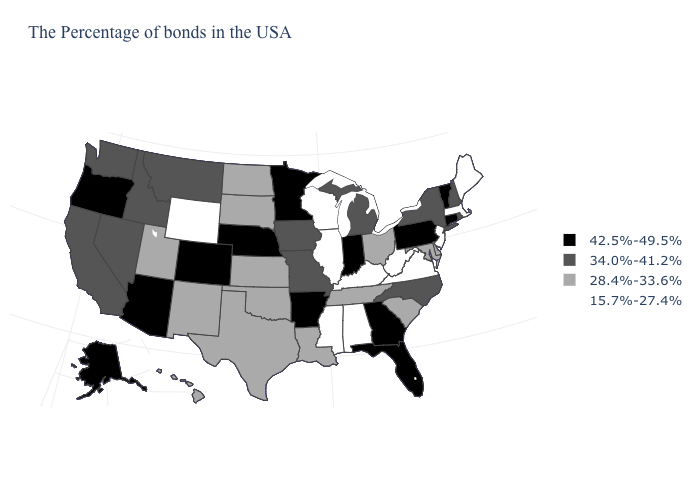How many symbols are there in the legend?
Answer briefly. 4. Does Vermont have the highest value in the USA?
Concise answer only. Yes. What is the lowest value in the USA?
Quick response, please. 15.7%-27.4%. Name the states that have a value in the range 34.0%-41.2%?
Be succinct. Rhode Island, New Hampshire, New York, North Carolina, Michigan, Missouri, Iowa, Montana, Idaho, Nevada, California, Washington. Does Michigan have the highest value in the MidWest?
Short answer required. No. What is the lowest value in the USA?
Short answer required. 15.7%-27.4%. What is the highest value in the USA?
Be succinct. 42.5%-49.5%. What is the lowest value in the USA?
Quick response, please. 15.7%-27.4%. What is the highest value in the South ?
Be succinct. 42.5%-49.5%. Which states have the lowest value in the MidWest?
Concise answer only. Wisconsin, Illinois. What is the lowest value in the West?
Answer briefly. 15.7%-27.4%. How many symbols are there in the legend?
Be succinct. 4. Which states have the highest value in the USA?
Write a very short answer. Vermont, Connecticut, Pennsylvania, Florida, Georgia, Indiana, Arkansas, Minnesota, Nebraska, Colorado, Arizona, Oregon, Alaska. What is the highest value in the South ?
Be succinct. 42.5%-49.5%. Name the states that have a value in the range 28.4%-33.6%?
Answer briefly. Delaware, Maryland, South Carolina, Ohio, Tennessee, Louisiana, Kansas, Oklahoma, Texas, South Dakota, North Dakota, New Mexico, Utah, Hawaii. 